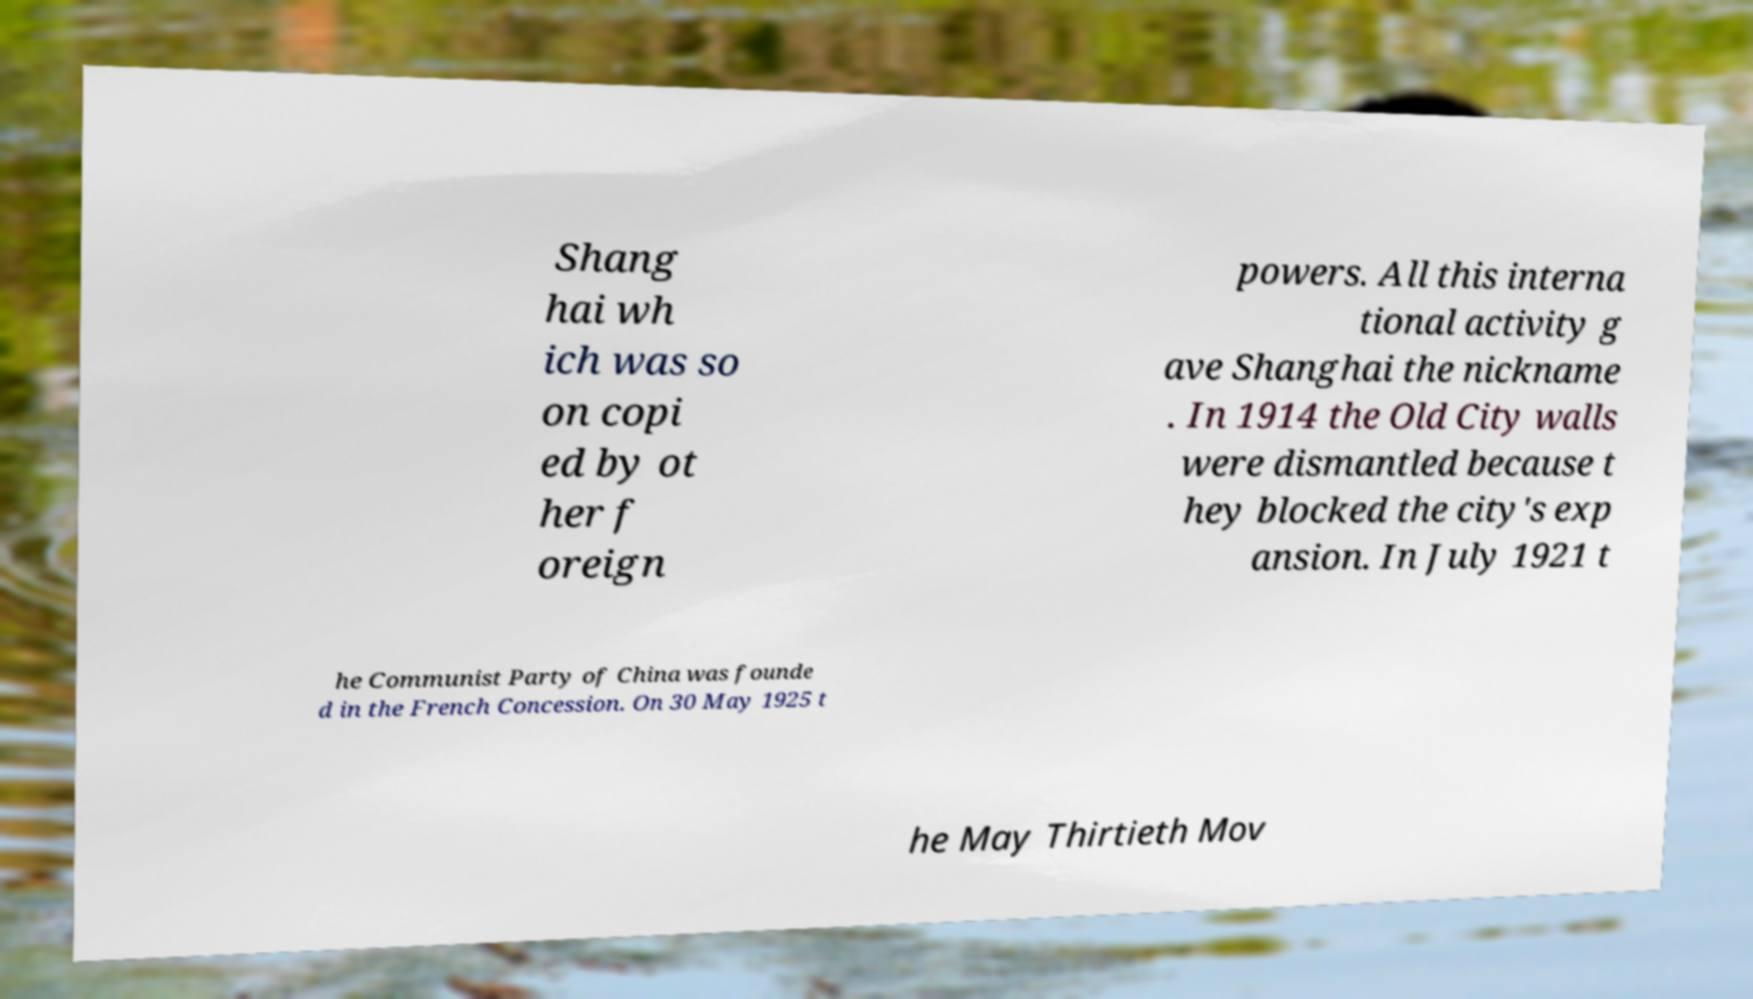Can you read and provide the text displayed in the image?This photo seems to have some interesting text. Can you extract and type it out for me? Shang hai wh ich was so on copi ed by ot her f oreign powers. All this interna tional activity g ave Shanghai the nickname . In 1914 the Old City walls were dismantled because t hey blocked the city's exp ansion. In July 1921 t he Communist Party of China was founde d in the French Concession. On 30 May 1925 t he May Thirtieth Mov 